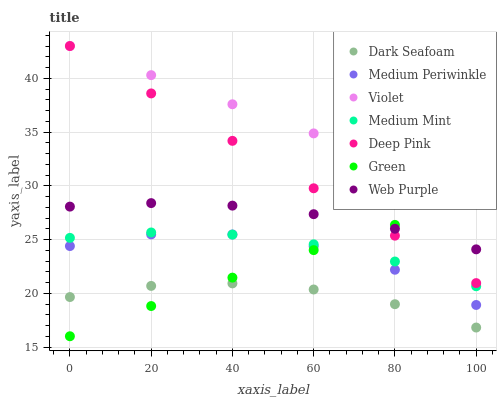Does Dark Seafoam have the minimum area under the curve?
Answer yes or no. Yes. Does Violet have the maximum area under the curve?
Answer yes or no. Yes. Does Deep Pink have the minimum area under the curve?
Answer yes or no. No. Does Deep Pink have the maximum area under the curve?
Answer yes or no. No. Is Violet the smoothest?
Answer yes or no. Yes. Is Medium Periwinkle the roughest?
Answer yes or no. Yes. Is Deep Pink the smoothest?
Answer yes or no. No. Is Deep Pink the roughest?
Answer yes or no. No. Does Green have the lowest value?
Answer yes or no. Yes. Does Deep Pink have the lowest value?
Answer yes or no. No. Does Violet have the highest value?
Answer yes or no. Yes. Does Medium Periwinkle have the highest value?
Answer yes or no. No. Is Medium Periwinkle less than Violet?
Answer yes or no. Yes. Is Violet greater than Medium Mint?
Answer yes or no. Yes. Does Green intersect Medium Periwinkle?
Answer yes or no. Yes. Is Green less than Medium Periwinkle?
Answer yes or no. No. Is Green greater than Medium Periwinkle?
Answer yes or no. No. Does Medium Periwinkle intersect Violet?
Answer yes or no. No. 